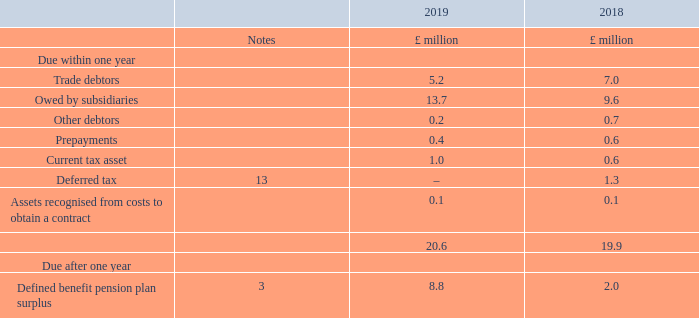9. Debtors
The Directors consider that the carrying amount of trade and other debtors approximates their fair value.
The Company has no significant concentration of credit risk attributable to its trade debtors as the exposure is spread over a large number of customers.
Assets recognised from costs to obtain a contract relate to capitalised incremental costs to obtain a contract, being sales commissions arising on contracts with customers of more than one year in length. No assets were impaired or derecognised during the current year or prior year.
Why does the Company have no significant concentration of credit risk attributable to its trade debtors? As the exposure is spread over a large number of customers. What do the assets recognised from costs to obtain a contract relate to? Capitalised incremental costs to obtain a contract, being sales commissions arising on contracts with customers of more than one year in length. What are the components under Due within one year? Trade debtors, owed by subsidiaries, other debtors, prepayments, current tax asset, deferred tax, assets recognised from costs to obtain a contract. In which year was the amount due within one year larger? 20.6>19.9
Answer: 2019. What was the change in the amount owed by subsidiaries?
Answer scale should be: million. 13.7-9.6
Answer: 4.1. What was the percentage change in the amount owed by subsidiaries?
Answer scale should be: percent. (13.7-9.6)/9.6
Answer: 42.71. 